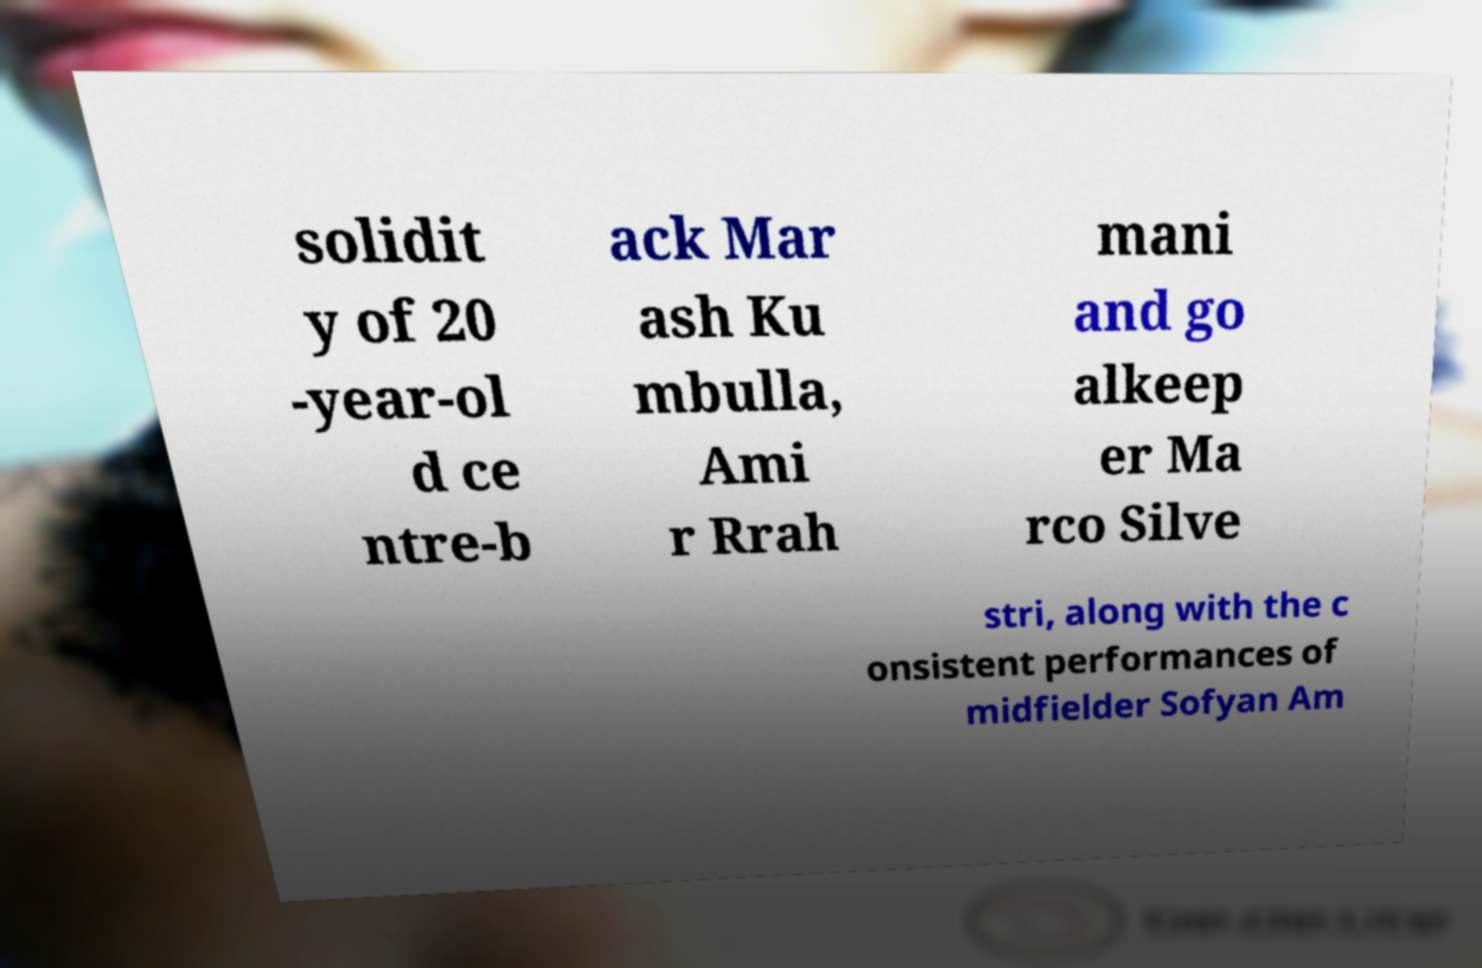Please identify and transcribe the text found in this image. solidit y of 20 -year-ol d ce ntre-b ack Mar ash Ku mbulla, Ami r Rrah mani and go alkeep er Ma rco Silve stri, along with the c onsistent performances of midfielder Sofyan Am 